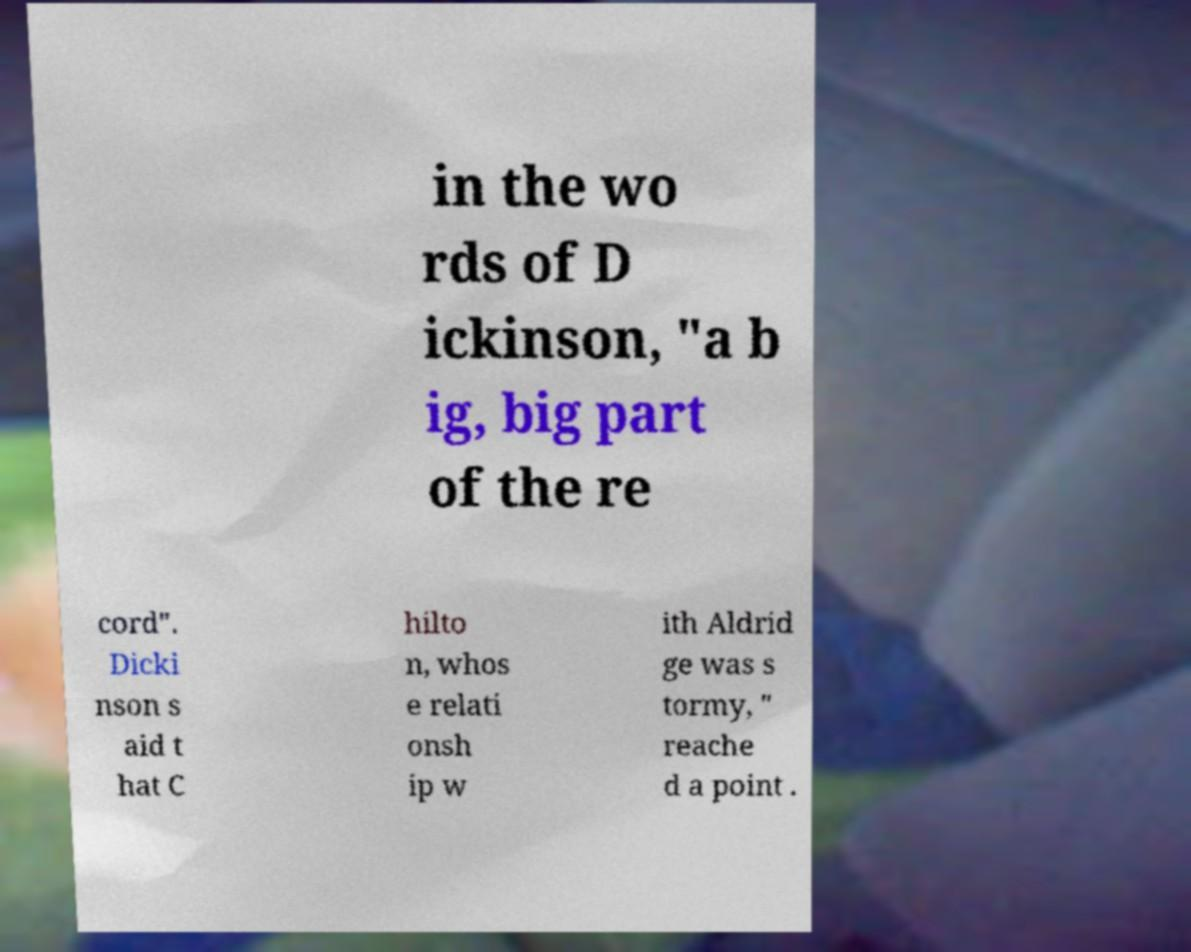Please identify and transcribe the text found in this image. in the wo rds of D ickinson, "a b ig, big part of the re cord". Dicki nson s aid t hat C hilto n, whos e relati onsh ip w ith Aldrid ge was s tormy, " reache d a point . 